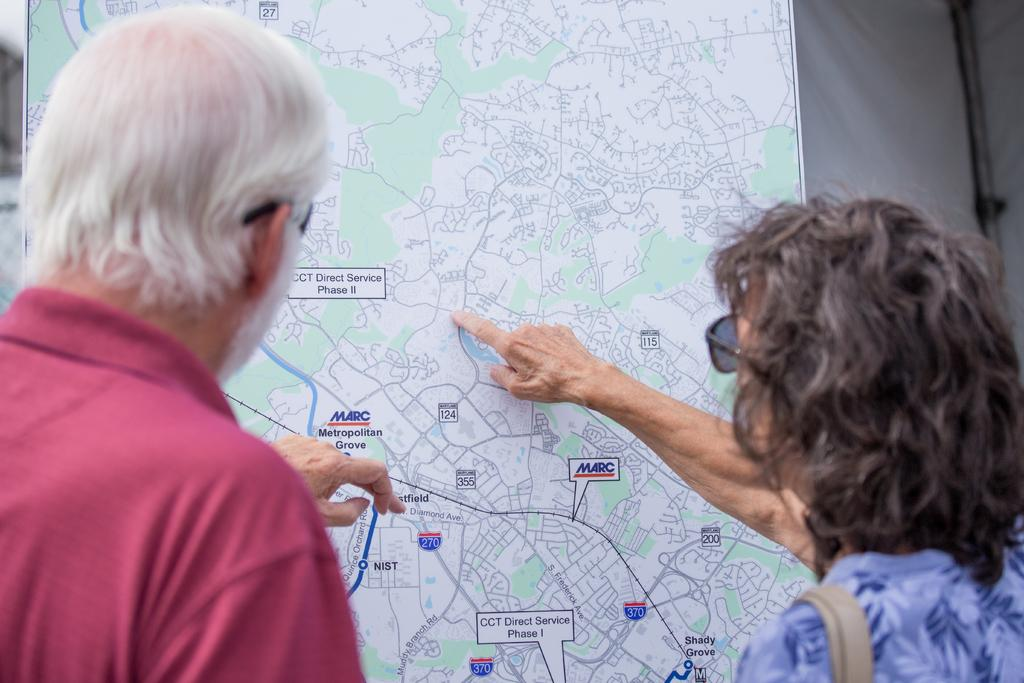Who is present in the image? There is a man and a lady in the image. What are the man and lady doing in the image? The man and lady are looking at a route map. Where is the faucet located in the image? There is no faucet present in the image. What type of bike is the lady riding in the image? There is no bike present in the image. 